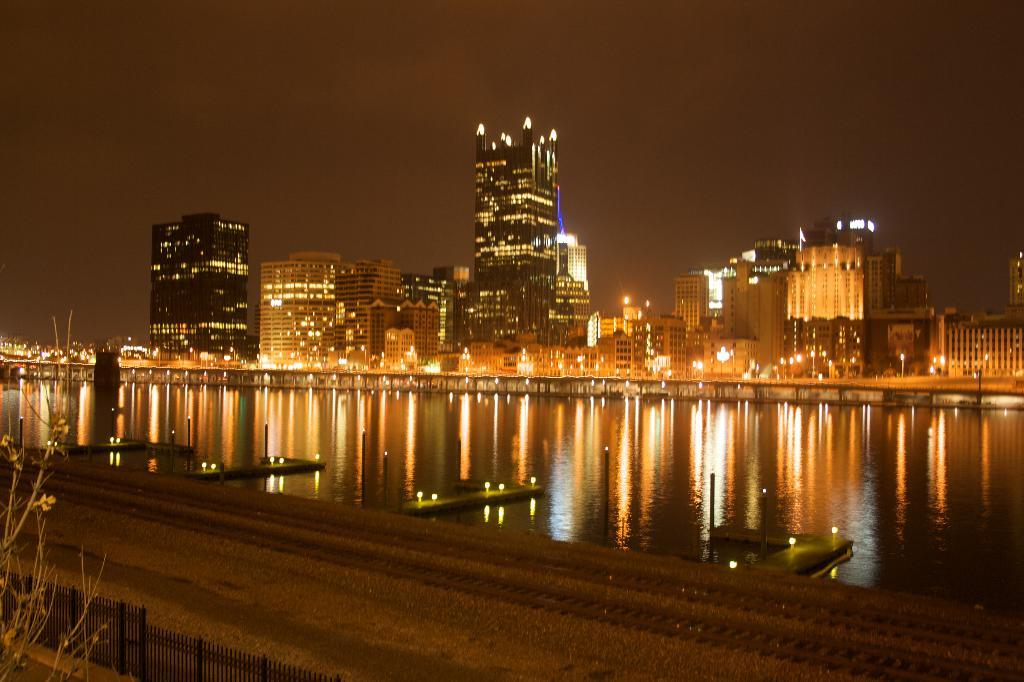What is the main feature in the center of the image? There is a lake in the center of the image. What can be seen in the background of the image? There are buildings and lights in the background of the image. What is located at the bottom of the image? There is a fence and a road at the bottom of the image. What is visible at the top of the image? The sky is visible at the top of the image. Can you see the toy that the child is smiling at in the image? There is no child or toy present in the image; it features a lake, buildings, lights, a fence, a road, and the sky. 